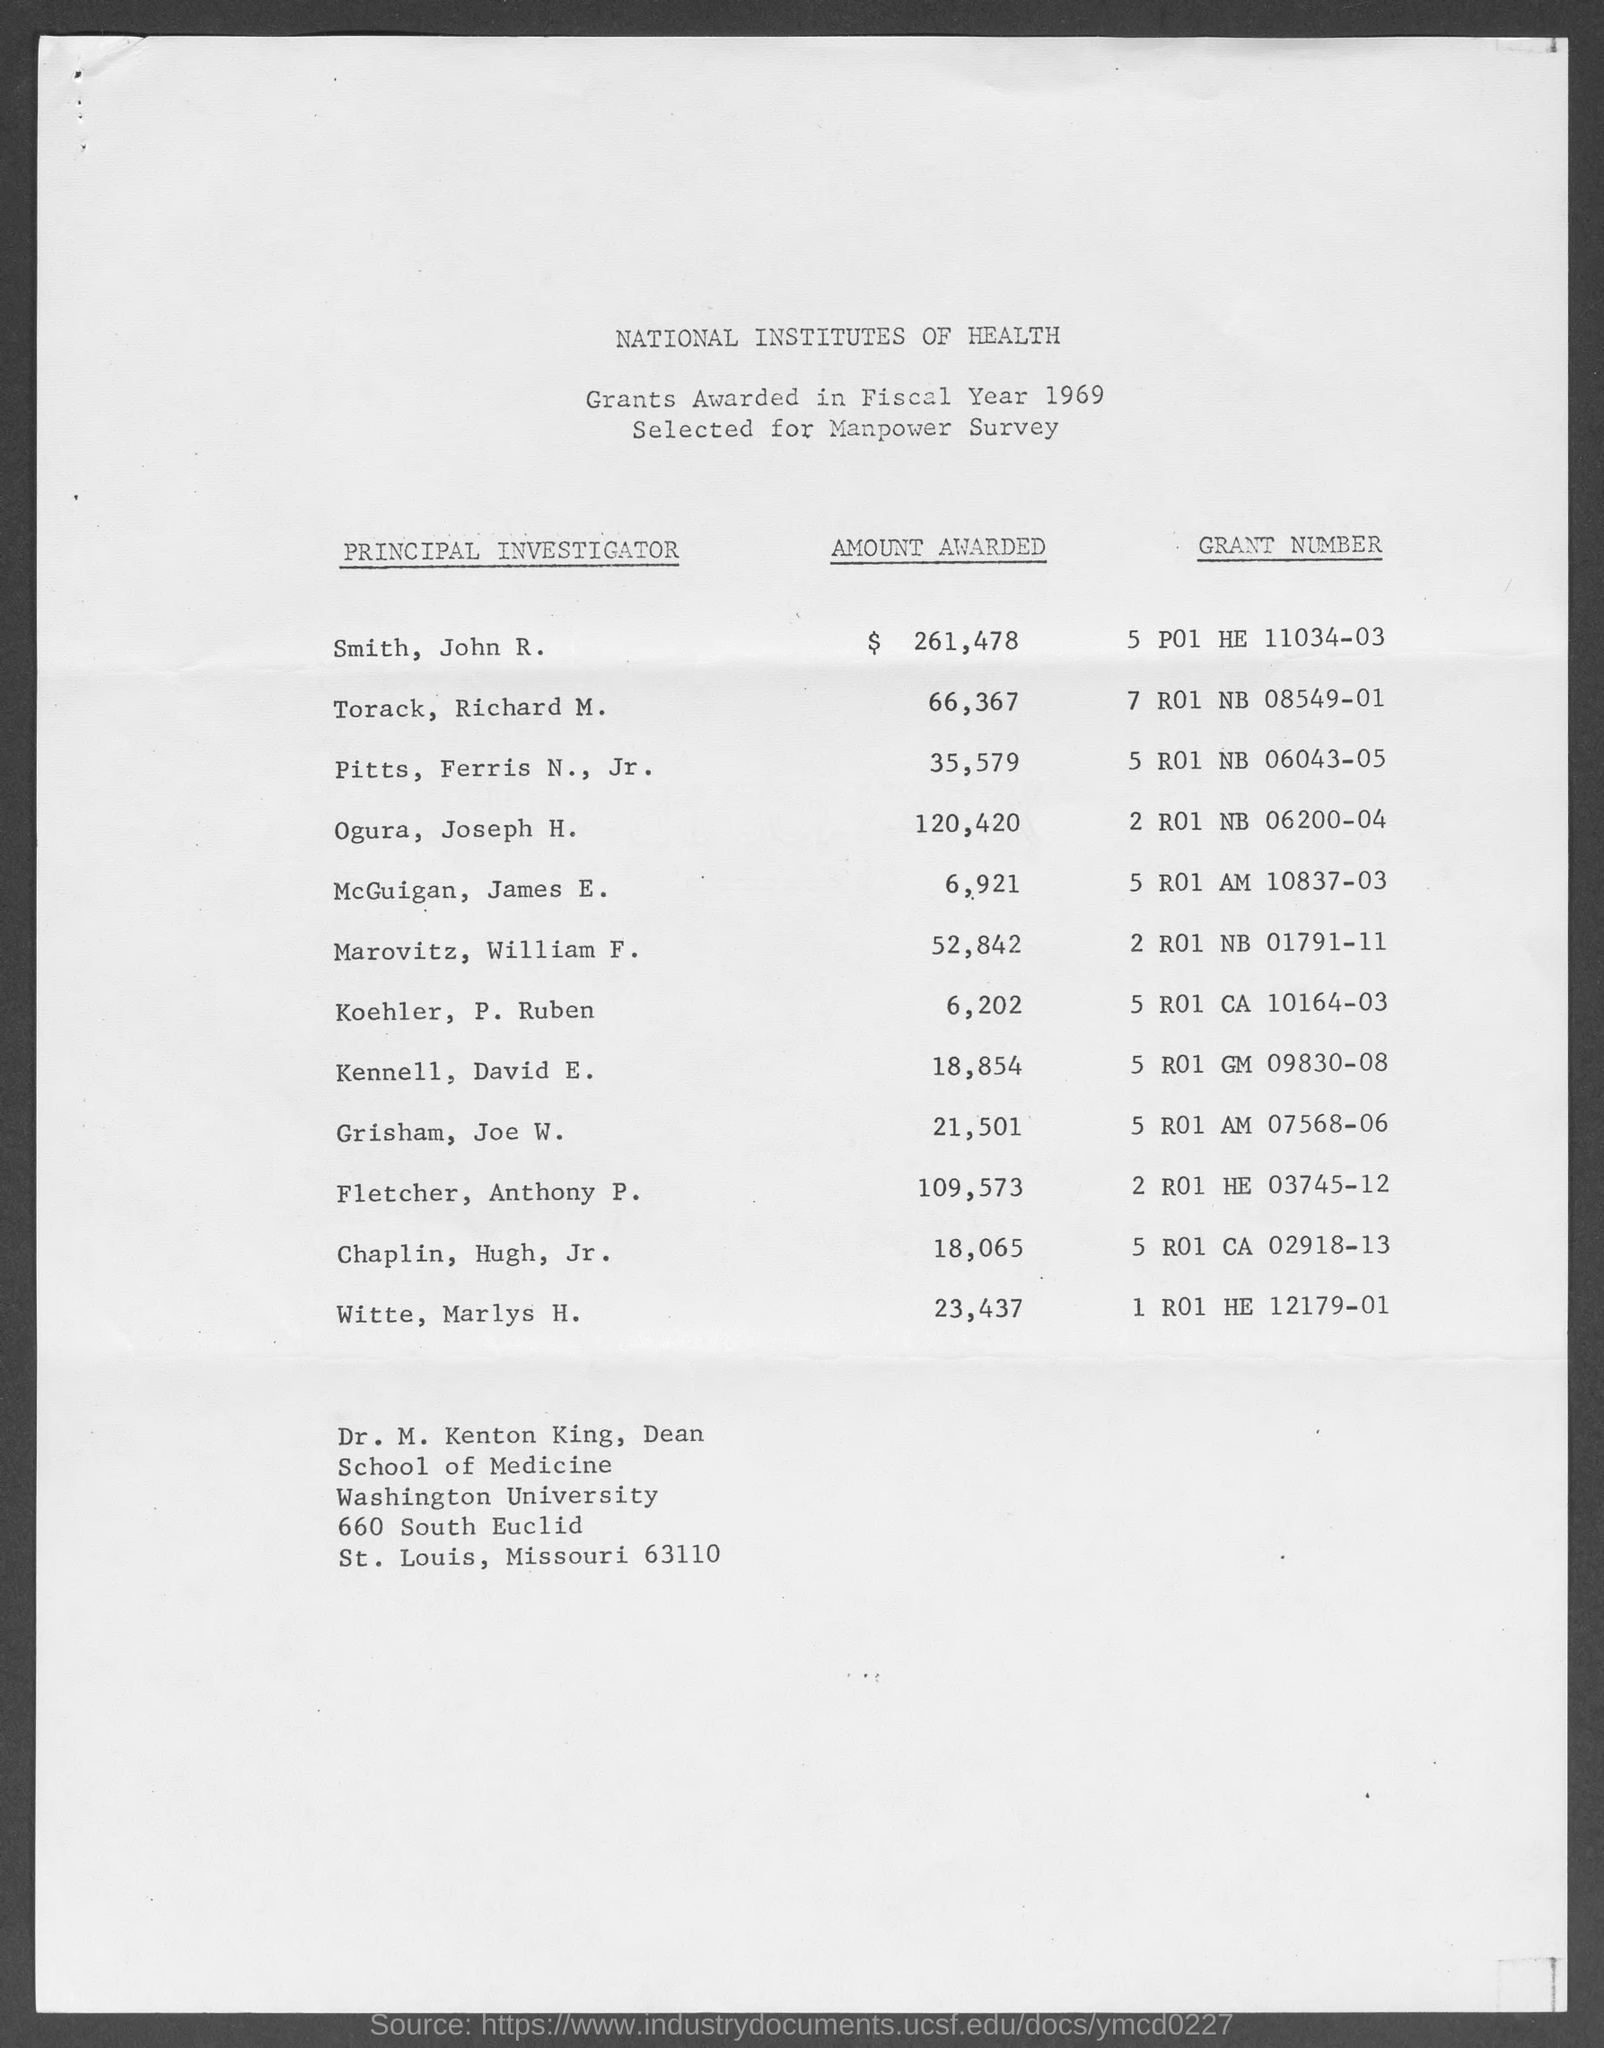In which fiscal year were grants awarded ?
Offer a terse response. 1969. What amount did smith, john r. got awarded with?
Your response must be concise. $ 261,478. What is the grant number related to smith, john r.?
Your response must be concise. 5 p01 he 11034-03. What is the grant number related to torack, richard m. ?
Ensure brevity in your answer.  7 r01 nb 08549-01. What is the grant number related to pitts, ferris n., jr.?
Ensure brevity in your answer.  5 R01 NB 06043-05. What is the grant number related to ogura, joseph h.?
Your response must be concise. 2 R01 nb 06200-04. Who is the dean, school of medicine, washington university?
Offer a very short reply. Dr. m. kenton king. 